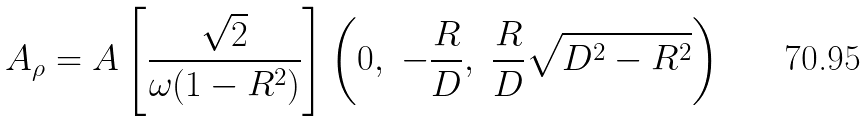Convert formula to latex. <formula><loc_0><loc_0><loc_500><loc_500>A _ { \rho } = A \left [ \frac { \sqrt { 2 } } { \omega ( 1 - R ^ { 2 } ) } \right ] \left ( 0 , \ - \frac { R } { D } , \ \frac { R } { D } \sqrt { D ^ { 2 } - R ^ { 2 } } \right )</formula> 